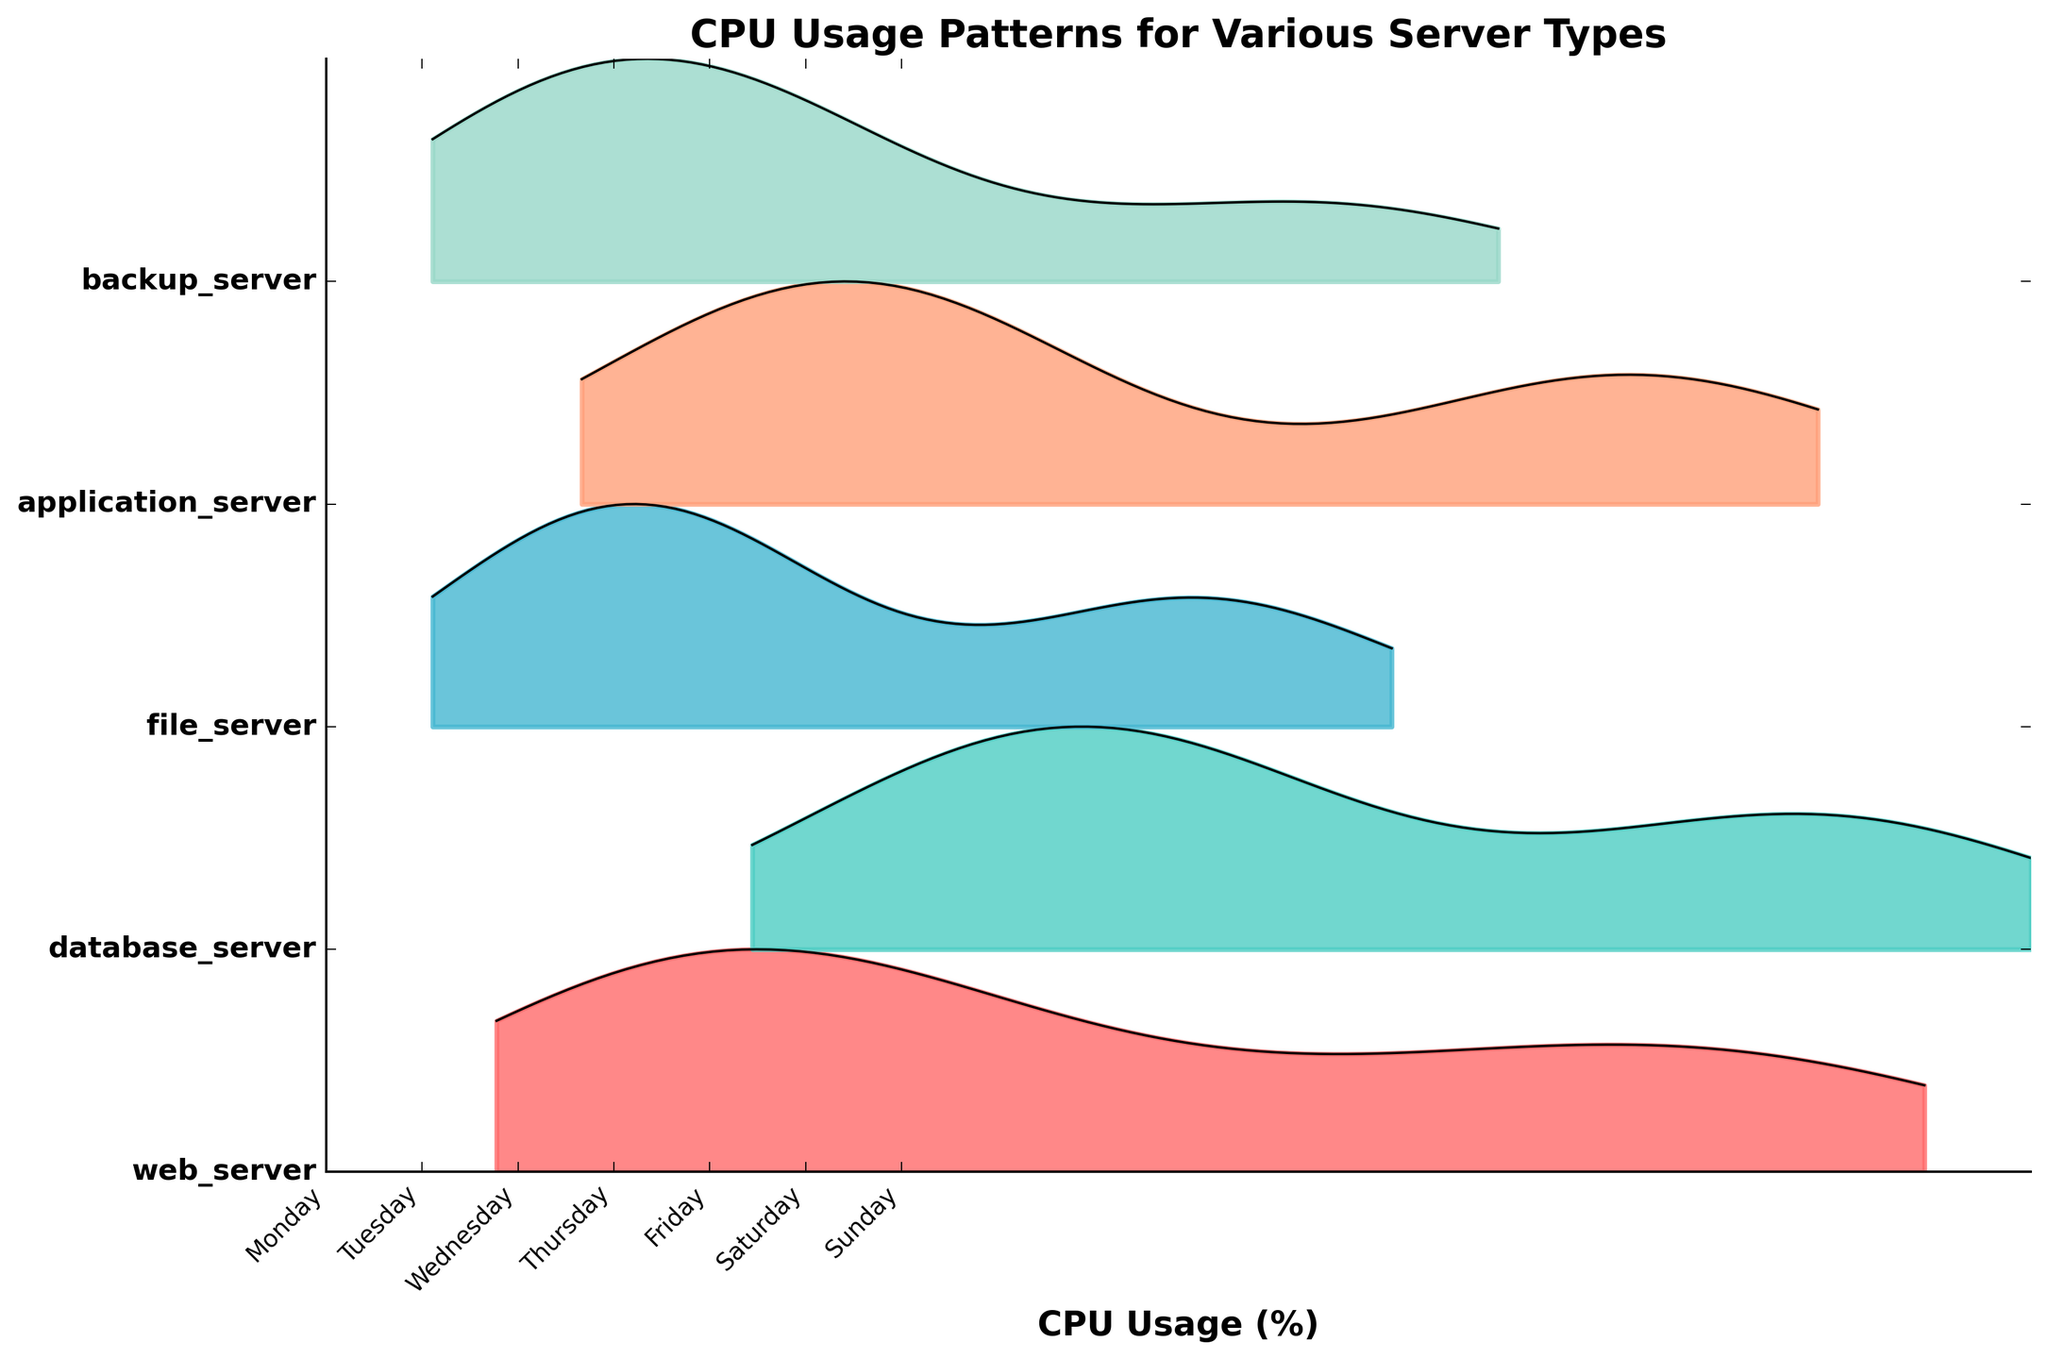What's the title of the plot? The title of the plot is displayed prominently at the top of the figure. It gives a brief description, helping viewers understand what the figure represents.
Answer: CPU Usage Patterns for Various Server Types What does the x-axis represent? The x-axis is labeled "CPU Usage (%)". It shows the range of CPU usage percentages across different server types and times.
Answer: CPU Usage (%) How many server types are displayed in the plot? The y-axis lists the server types. By counting the labels, you can see there are five server types displayed.
Answer: Five Which server type has the highest CPU usage peak on Monday at noon? By observing the ridges for different server types at the point representing Monday at 12:00, you can see which one reaches the highest point.
Answer: Database Server Does the web server ever reach a CPU usage above 70% during the week? To find this, look at the ridges for the web server and check if any peak goes above the 70% mark throughout the span of the plot.
Answer: No On which day does the backup server have its highest CPU usage, and what is it approximately? Examine the ridgeline for the backup server and identify the day and point where it reaches its maximum.
Answer: Sunday, approximately 55% Which day shows the most balanced CPU usage across all server types? Balance can be inferred when the ridges are relatively even and not having extreme peaks or troughs within a day across all server types. Compare the days visually.
Answer: Wednesday How does the CPU usage pattern for the file server on Friday at noon compare to its usage on Monday at noon? Compare the heights of the ridges for the file server at the points representing Friday at 12:00 and Monday at 12:00. Identify which is higher or if they are similar.
Answer: Slightly higher on Friday Which two server types have the most similar CPU usage patterns throughout the week? Find pairs of ridgelines that have similar shapes and peaks during the week. Observing the entire plot will help identify the pair.
Answer: Application Server and File Server How does the CPU usage of the web server at midnight vary from Monday to Sunday? Look at the points for the web server at 00:00 on each day and observe the trends. Note the variations for each day.
Answer: It peaks midweek and drops towards the weekend 